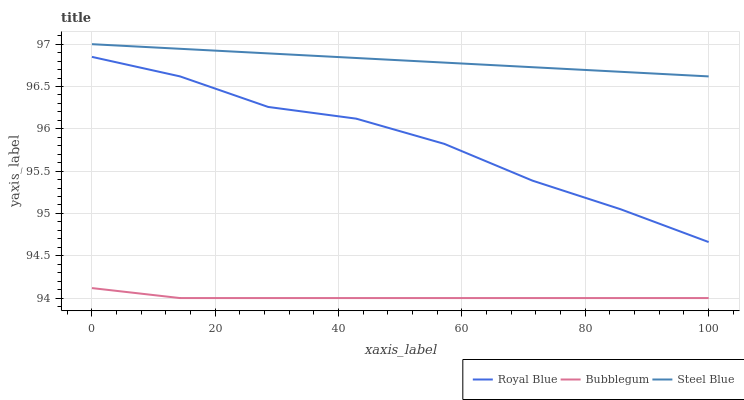Does Steel Blue have the minimum area under the curve?
Answer yes or no. No. Does Bubblegum have the maximum area under the curve?
Answer yes or no. No. Is Bubblegum the smoothest?
Answer yes or no. No. Is Bubblegum the roughest?
Answer yes or no. No. Does Steel Blue have the lowest value?
Answer yes or no. No. Does Bubblegum have the highest value?
Answer yes or no. No. Is Bubblegum less than Royal Blue?
Answer yes or no. Yes. Is Steel Blue greater than Royal Blue?
Answer yes or no. Yes. Does Bubblegum intersect Royal Blue?
Answer yes or no. No. 